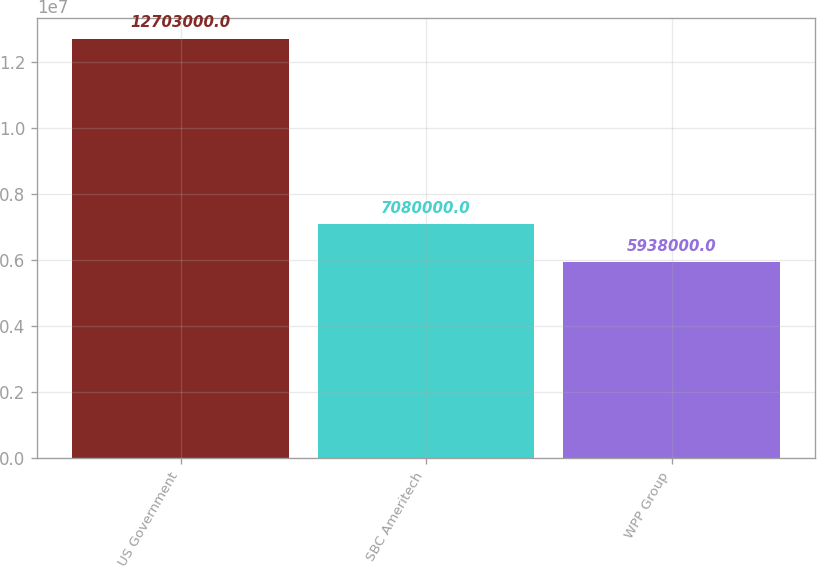Convert chart. <chart><loc_0><loc_0><loc_500><loc_500><bar_chart><fcel>US Government<fcel>SBC Ameritech<fcel>WPP Group<nl><fcel>1.2703e+07<fcel>7.08e+06<fcel>5.938e+06<nl></chart> 